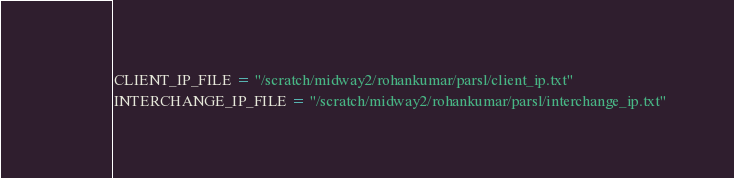<code> <loc_0><loc_0><loc_500><loc_500><_Python_>CLIENT_IP_FILE = "/scratch/midway2/rohankumar/parsl/client_ip.txt"
INTERCHANGE_IP_FILE = "/scratch/midway2/rohankumar/parsl/interchange_ip.txt"
</code> 